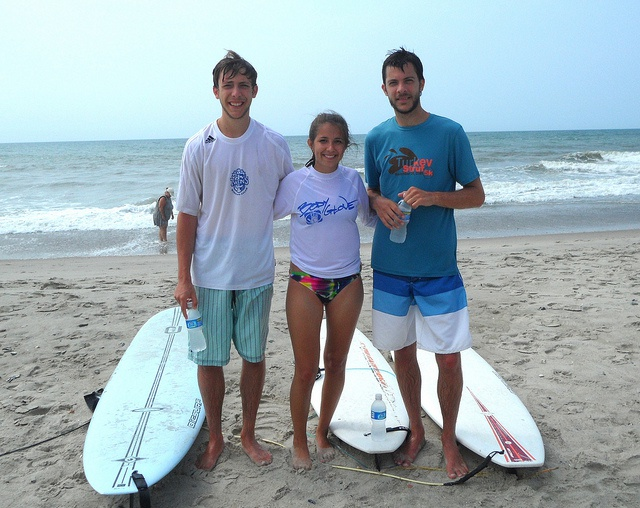Describe the objects in this image and their specific colors. I can see people in white, blue, teal, gray, and navy tones, people in white, darkgray, and gray tones, people in white, maroon, darkgray, and gray tones, surfboard in white, lightblue, black, and gray tones, and surfboard in white, darkgray, black, and gray tones in this image. 